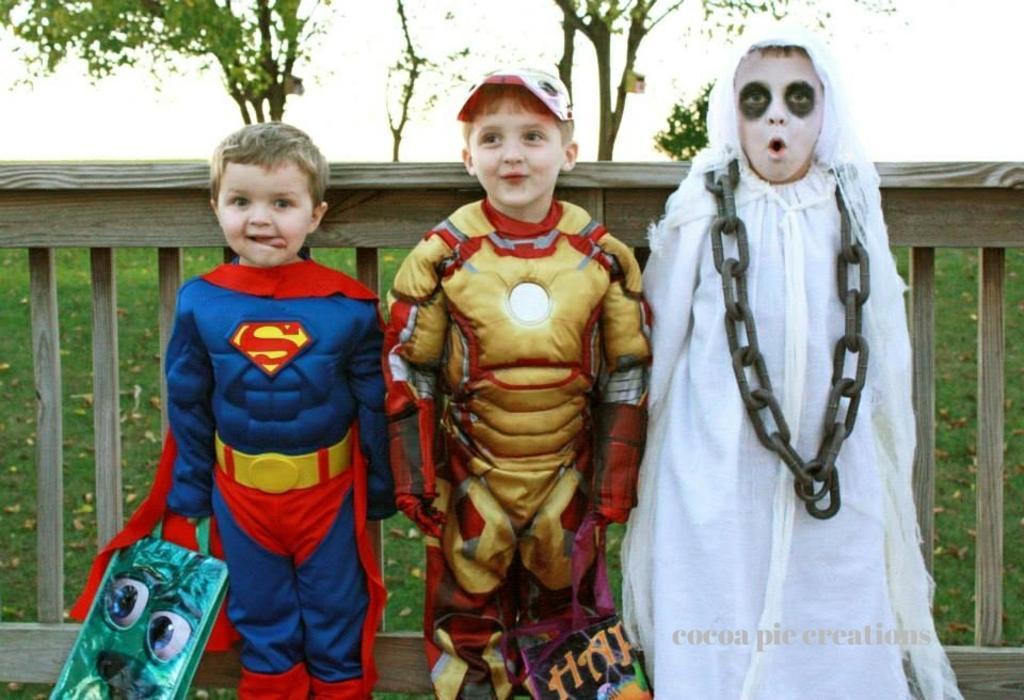Can you describe this image briefly? In this image there are three kids wearing costumes, in the background there is a wooden fencing, grassland and tree, in the bottom right there is text. 